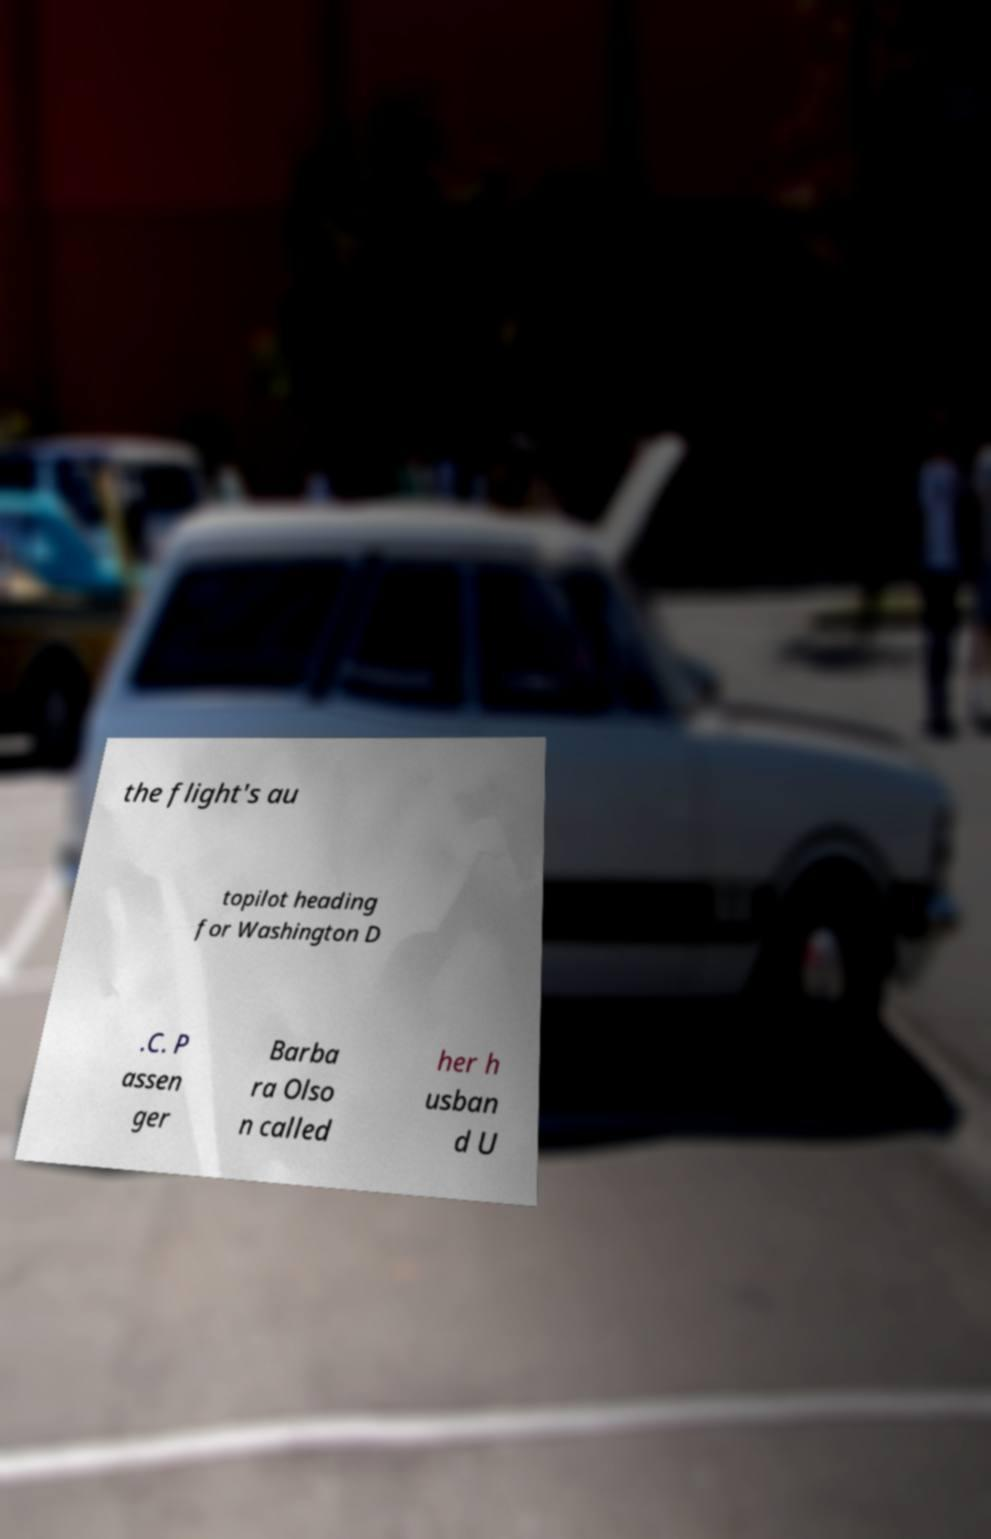Can you accurately transcribe the text from the provided image for me? the flight's au topilot heading for Washington D .C. P assen ger Barba ra Olso n called her h usban d U 